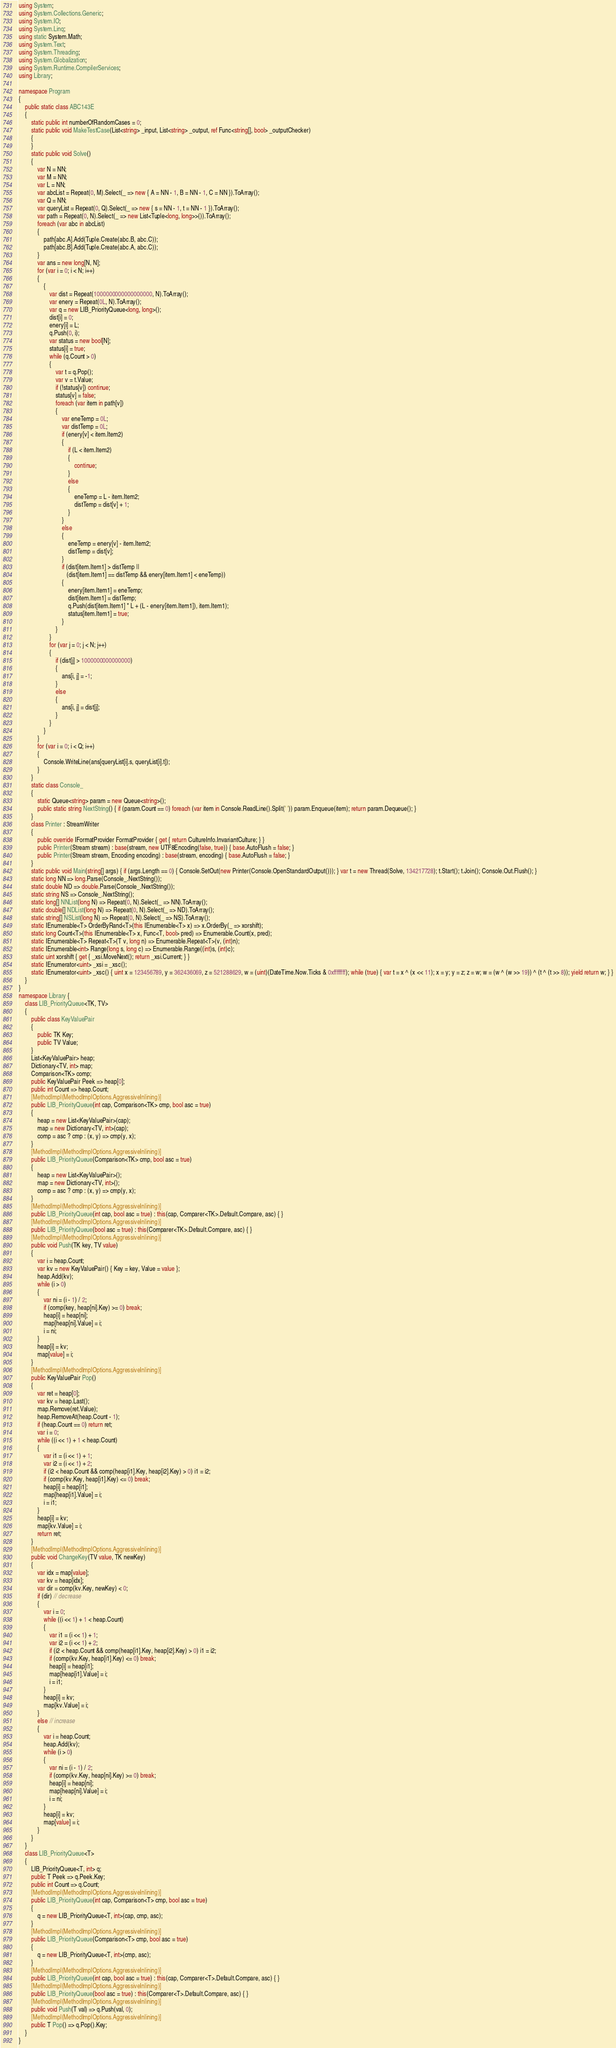<code> <loc_0><loc_0><loc_500><loc_500><_C#_>using System;
using System.Collections.Generic;
using System.IO;
using System.Linq;
using static System.Math;
using System.Text;
using System.Threading;
using System.Globalization;
using System.Runtime.CompilerServices;
using Library;

namespace Program
{
    public static class ABC143E
    {
        static public int numberOfRandomCases = 0;
        static public void MakeTestCase(List<string> _input, List<string> _output, ref Func<string[], bool> _outputChecker)
        {
        }
        static public void Solve()
        {
            var N = NN;
            var M = NN;
            var L = NN;
            var abcList = Repeat(0, M).Select(_ => new { A = NN - 1, B = NN - 1, C = NN }).ToArray();
            var Q = NN;
            var queryList = Repeat(0, Q).Select(_ => new { s = NN - 1, t = NN - 1 }).ToArray();
            var path = Repeat(0, N).Select(_ => new List<Tuple<long, long>>()).ToArray();
            foreach (var abc in abcList)
            {
                path[abc.A].Add(Tuple.Create(abc.B, abc.C));
                path[abc.B].Add(Tuple.Create(abc.A, abc.C));
            }
            var ans = new long[N, N];
            for (var i = 0; i < N; i++)
            {
                {
                    var dist = Repeat(1000000000000000000, N).ToArray();
                    var enery = Repeat(0L, N).ToArray();
                    var q = new LIB_PriorityQueue<long, long>();
                    dist[i] = 0;
                    enery[i] = L;
                    q.Push(0, i);
                    var status = new bool[N];
                    status[i] = true;
                    while (q.Count > 0)
                    {
                        var t = q.Pop();
                        var v = t.Value;
                        if (!status[v]) continue;
                        status[v] = false;
                        foreach (var item in path[v])
                        {
                            var eneTemp = 0L;
                            var distTemp = 0L;
                            if (enery[v] < item.Item2)
                            {
                                if (L < item.Item2)
                                {
                                    continue;
                                }
                                else
                                {
                                    eneTemp = L - item.Item2;
                                    distTemp = dist[v] + 1;
                                }
                            }
                            else
                            {
                                eneTemp = enery[v] - item.Item2;
                                distTemp = dist[v];
                            }
                            if (dist[item.Item1] > distTemp ||
                               (dist[item.Item1] == distTemp && enery[item.Item1] < eneTemp))
                            {
                                enery[item.Item1] = eneTemp;
                                dist[item.Item1] = distTemp;
                                q.Push(dist[item.Item1] * L + (L - enery[item.Item1]), item.Item1);
                                status[item.Item1] = true;
                            }
                        }
                    }
                    for (var j = 0; j < N; j++)
                    {
                        if (dist[j] > 1000000000000000)
                        {
                            ans[i, j] = -1;
                        }
                        else
                        {
                            ans[i, j] = dist[j];
                        }
                    }
                }
            }
            for (var i = 0; i < Q; i++)
            {
                Console.WriteLine(ans[queryList[i].s, queryList[i].t]);
            }
        }
        static class Console_
        {
            static Queue<string> param = new Queue<string>();
            public static string NextString() { if (param.Count == 0) foreach (var item in Console.ReadLine().Split(' ')) param.Enqueue(item); return param.Dequeue(); }
        }
        class Printer : StreamWriter
        {
            public override IFormatProvider FormatProvider { get { return CultureInfo.InvariantCulture; } }
            public Printer(Stream stream) : base(stream, new UTF8Encoding(false, true)) { base.AutoFlush = false; }
            public Printer(Stream stream, Encoding encoding) : base(stream, encoding) { base.AutoFlush = false; }
        }
        static public void Main(string[] args) { if (args.Length == 0) { Console.SetOut(new Printer(Console.OpenStandardOutput())); } var t = new Thread(Solve, 134217728); t.Start(); t.Join(); Console.Out.Flush(); }
        static long NN => long.Parse(Console_.NextString());
        static double ND => double.Parse(Console_.NextString());
        static string NS => Console_.NextString();
        static long[] NNList(long N) => Repeat(0, N).Select(_ => NN).ToArray();
        static double[] NDList(long N) => Repeat(0, N).Select(_ => ND).ToArray();
        static string[] NSList(long N) => Repeat(0, N).Select(_ => NS).ToArray();
        static IEnumerable<T> OrderByRand<T>(this IEnumerable<T> x) => x.OrderBy(_ => xorshift);
        static long Count<T>(this IEnumerable<T> x, Func<T, bool> pred) => Enumerable.Count(x, pred);
        static IEnumerable<T> Repeat<T>(T v, long n) => Enumerable.Repeat<T>(v, (int)n);
        static IEnumerable<int> Range(long s, long c) => Enumerable.Range((int)s, (int)c);
        static uint xorshift { get { _xsi.MoveNext(); return _xsi.Current; } }
        static IEnumerator<uint> _xsi = _xsc();
        static IEnumerator<uint> _xsc() { uint x = 123456789, y = 362436069, z = 521288629, w = (uint)(DateTime.Now.Ticks & 0xffffffff); while (true) { var t = x ^ (x << 11); x = y; y = z; z = w; w = (w ^ (w >> 19)) ^ (t ^ (t >> 8)); yield return w; } }
    }
}
namespace Library {
    class LIB_PriorityQueue<TK, TV>
    {
        public class KeyValuePair
        {
            public TK Key;
            public TV Value;
        }
        List<KeyValuePair> heap;
        Dictionary<TV, int> map;
        Comparison<TK> comp;
        public KeyValuePair Peek => heap[0];
        public int Count => heap.Count;
        [MethodImpl(MethodImplOptions.AggressiveInlining)]
        public LIB_PriorityQueue(int cap, Comparison<TK> cmp, bool asc = true)
        {
            heap = new List<KeyValuePair>(cap);
            map = new Dictionary<TV, int>(cap);
            comp = asc ? cmp : (x, y) => cmp(y, x);
        }
        [MethodImpl(MethodImplOptions.AggressiveInlining)]
        public LIB_PriorityQueue(Comparison<TK> cmp, bool asc = true)
        {
            heap = new List<KeyValuePair>();
            map = new Dictionary<TV, int>();
            comp = asc ? cmp : (x, y) => cmp(y, x);
        }
        [MethodImpl(MethodImplOptions.AggressiveInlining)]
        public LIB_PriorityQueue(int cap, bool asc = true) : this(cap, Comparer<TK>.Default.Compare, asc) { }
        [MethodImpl(MethodImplOptions.AggressiveInlining)]
        public LIB_PriorityQueue(bool asc = true) : this(Comparer<TK>.Default.Compare, asc) { }
        [MethodImpl(MethodImplOptions.AggressiveInlining)]
        public void Push(TK key, TV value)
        {
            var i = heap.Count;
            var kv = new KeyValuePair() { Key = key, Value = value };
            heap.Add(kv);
            while (i > 0)
            {
                var ni = (i - 1) / 2;
                if (comp(key, heap[ni].Key) >= 0) break;
                heap[i] = heap[ni];
                map[heap[ni].Value] = i;
                i = ni;
            }
            heap[i] = kv;
            map[value] = i;
        }
        [MethodImpl(MethodImplOptions.AggressiveInlining)]
        public KeyValuePair Pop()
        {
            var ret = heap[0];
            var kv = heap.Last();
            map.Remove(ret.Value);
            heap.RemoveAt(heap.Count - 1);
            if (heap.Count == 0) return ret;
            var i = 0;
            while ((i << 1) + 1 < heap.Count)
            {
                var i1 = (i << 1) + 1;
                var i2 = (i << 1) + 2;
                if (i2 < heap.Count && comp(heap[i1].Key, heap[i2].Key) > 0) i1 = i2;
                if (comp(kv.Key, heap[i1].Key) <= 0) break;
                heap[i] = heap[i1];
                map[heap[i1].Value] = i;
                i = i1;
            }
            heap[i] = kv;
            map[kv.Value] = i;
            return ret;
        }
        [MethodImpl(MethodImplOptions.AggressiveInlining)]
        public void ChangeKey(TV value, TK newKey)
        {
            var idx = map[value];
            var kv = heap[idx];
            var dir = comp(kv.Key, newKey) < 0;
            if (dir) // decrease
            {
                var i = 0;
                while ((i << 1) + 1 < heap.Count)
                {
                    var i1 = (i << 1) + 1;
                    var i2 = (i << 1) + 2;
                    if (i2 < heap.Count && comp(heap[i1].Key, heap[i2].Key) > 0) i1 = i2;
                    if (comp(kv.Key, heap[i1].Key) <= 0) break;
                    heap[i] = heap[i1];
                    map[heap[i1].Value] = i;
                    i = i1;
                }
                heap[i] = kv;
                map[kv.Value] = i;
            }
            else // increase
            {
                var i = heap.Count;
                heap.Add(kv);
                while (i > 0)
                {
                    var ni = (i - 1) / 2;
                    if (comp(kv.Key, heap[ni].Key) >= 0) break;
                    heap[i] = heap[ni];
                    map[heap[ni].Value] = i;
                    i = ni;
                }
                heap[i] = kv;
                map[value] = i;
            }
        }
    }
    class LIB_PriorityQueue<T>
    {
        LIB_PriorityQueue<T, int> q;
        public T Peek => q.Peek.Key;
        public int Count => q.Count;
        [MethodImpl(MethodImplOptions.AggressiveInlining)]
        public LIB_PriorityQueue(int cap, Comparison<T> cmp, bool asc = true)
        {
            q = new LIB_PriorityQueue<T, int>(cap, cmp, asc);
        }
        [MethodImpl(MethodImplOptions.AggressiveInlining)]
        public LIB_PriorityQueue(Comparison<T> cmp, bool asc = true)
        {
            q = new LIB_PriorityQueue<T, int>(cmp, asc);
        }
        [MethodImpl(MethodImplOptions.AggressiveInlining)]
        public LIB_PriorityQueue(int cap, bool asc = true) : this(cap, Comparer<T>.Default.Compare, asc) { }
        [MethodImpl(MethodImplOptions.AggressiveInlining)]
        public LIB_PriorityQueue(bool asc = true) : this(Comparer<T>.Default.Compare, asc) { }
        [MethodImpl(MethodImplOptions.AggressiveInlining)]
        public void Push(T val) => q.Push(val, 0);
        [MethodImpl(MethodImplOptions.AggressiveInlining)]
        public T Pop() => q.Pop().Key;
    }
}
</code> 